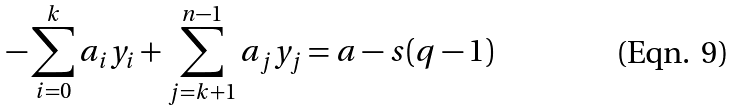<formula> <loc_0><loc_0><loc_500><loc_500>- \sum _ { i = 0 } ^ { k } a _ { i } y _ { i } + \sum _ { j = k + 1 } ^ { n - 1 } a _ { j } y _ { j } = a - s ( q - 1 )</formula> 